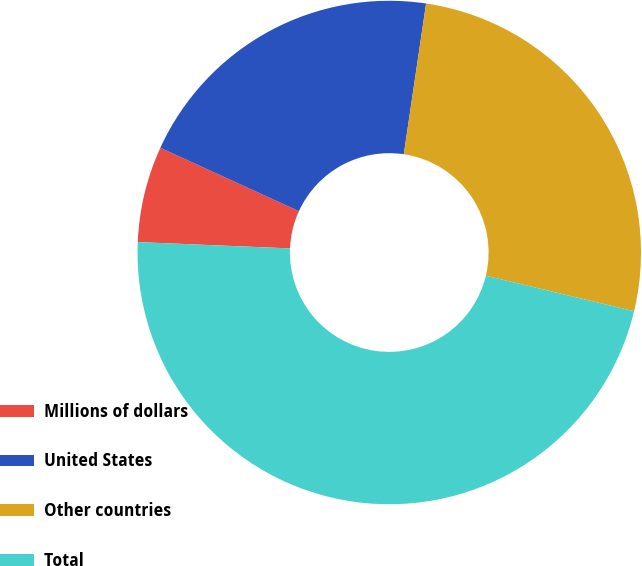Convert chart. <chart><loc_0><loc_0><loc_500><loc_500><pie_chart><fcel>Millions of dollars<fcel>United States<fcel>Other countries<fcel>Total<nl><fcel>6.17%<fcel>20.51%<fcel>26.41%<fcel>46.92%<nl></chart> 